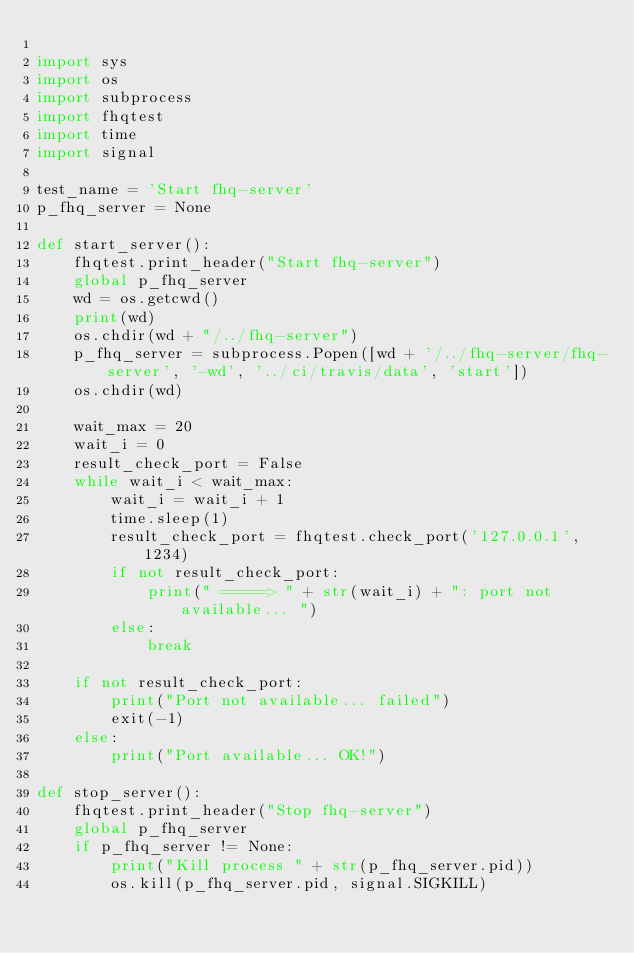Convert code to text. <code><loc_0><loc_0><loc_500><loc_500><_Python_>
import sys
import os
import subprocess
import fhqtest
import time
import signal

test_name = 'Start fhq-server'
p_fhq_server = None

def start_server():
    fhqtest.print_header("Start fhq-server")
    global p_fhq_server
    wd = os.getcwd()
    print(wd)
    os.chdir(wd + "/../fhq-server")
    p_fhq_server = subprocess.Popen([wd + '/../fhq-server/fhq-server', '-wd', '../ci/travis/data', 'start'])
    os.chdir(wd)

    wait_max = 20
    wait_i = 0
    result_check_port = False
    while wait_i < wait_max:
        wait_i = wait_i + 1
        time.sleep(1)
        result_check_port = fhqtest.check_port('127.0.0.1', 1234)
        if not result_check_port:
            print(" =====> " + str(wait_i) + ": port not available... ")
        else:
            break

    if not result_check_port:
        print("Port not available... failed")
        exit(-1)
    else:
        print("Port available... OK!")

def stop_server():
    fhqtest.print_header("Stop fhq-server")
    global p_fhq_server
    if p_fhq_server != None:
        print("Kill process " + str(p_fhq_server.pid))
        os.kill(p_fhq_server.pid, signal.SIGKILL)</code> 